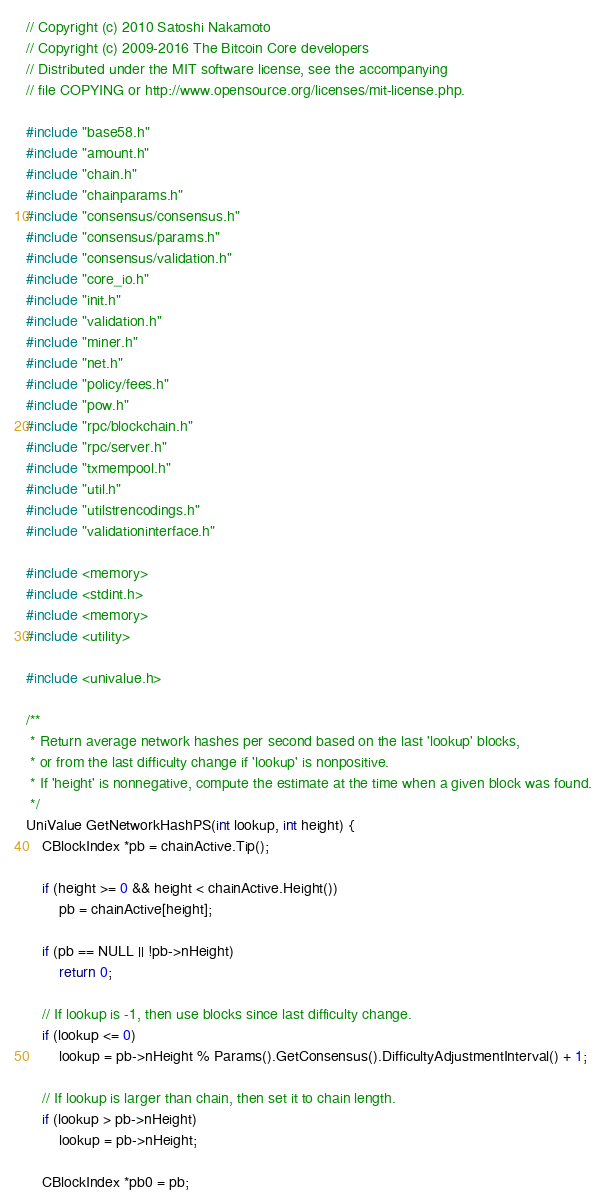<code> <loc_0><loc_0><loc_500><loc_500><_C++_>// Copyright (c) 2010 Satoshi Nakamoto
// Copyright (c) 2009-2016 The Bitcoin Core developers
// Distributed under the MIT software license, see the accompanying
// file COPYING or http://www.opensource.org/licenses/mit-license.php.

#include "base58.h"
#include "amount.h"
#include "chain.h"
#include "chainparams.h"
#include "consensus/consensus.h"
#include "consensus/params.h"
#include "consensus/validation.h"
#include "core_io.h"
#include "init.h"
#include "validation.h"
#include "miner.h"
#include "net.h"
#include "policy/fees.h"
#include "pow.h"
#include "rpc/blockchain.h"
#include "rpc/server.h"
#include "txmempool.h"
#include "util.h"
#include "utilstrencodings.h"
#include "validationinterface.h"

#include <memory>
#include <stdint.h>
#include <memory>
#include <utility>

#include <univalue.h>

/**
 * Return average network hashes per second based on the last 'lookup' blocks,
 * or from the last difficulty change if 'lookup' is nonpositive.
 * If 'height' is nonnegative, compute the estimate at the time when a given block was found.
 */
UniValue GetNetworkHashPS(int lookup, int height) {
    CBlockIndex *pb = chainActive.Tip();

    if (height >= 0 && height < chainActive.Height())
        pb = chainActive[height];

    if (pb == NULL || !pb->nHeight)
        return 0;

    // If lookup is -1, then use blocks since last difficulty change.
    if (lookup <= 0)
        lookup = pb->nHeight % Params().GetConsensus().DifficultyAdjustmentInterval() + 1;

    // If lookup is larger than chain, then set it to chain length.
    if (lookup > pb->nHeight)
        lookup = pb->nHeight;

    CBlockIndex *pb0 = pb;</code> 